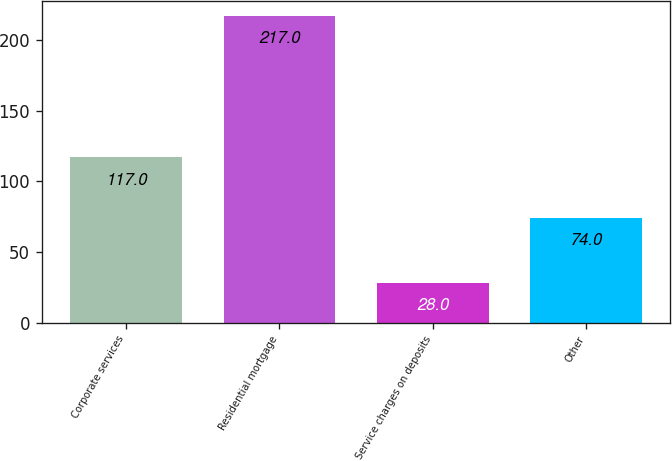Convert chart to OTSL. <chart><loc_0><loc_0><loc_500><loc_500><bar_chart><fcel>Corporate services<fcel>Residential mortgage<fcel>Service charges on deposits<fcel>Other<nl><fcel>117<fcel>217<fcel>28<fcel>74<nl></chart> 